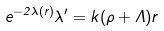Convert formula to latex. <formula><loc_0><loc_0><loc_500><loc_500>e ^ { - { 2 \lambda ( r ) } } \lambda ^ { \prime } = k ( \rho + \Lambda ) r</formula> 